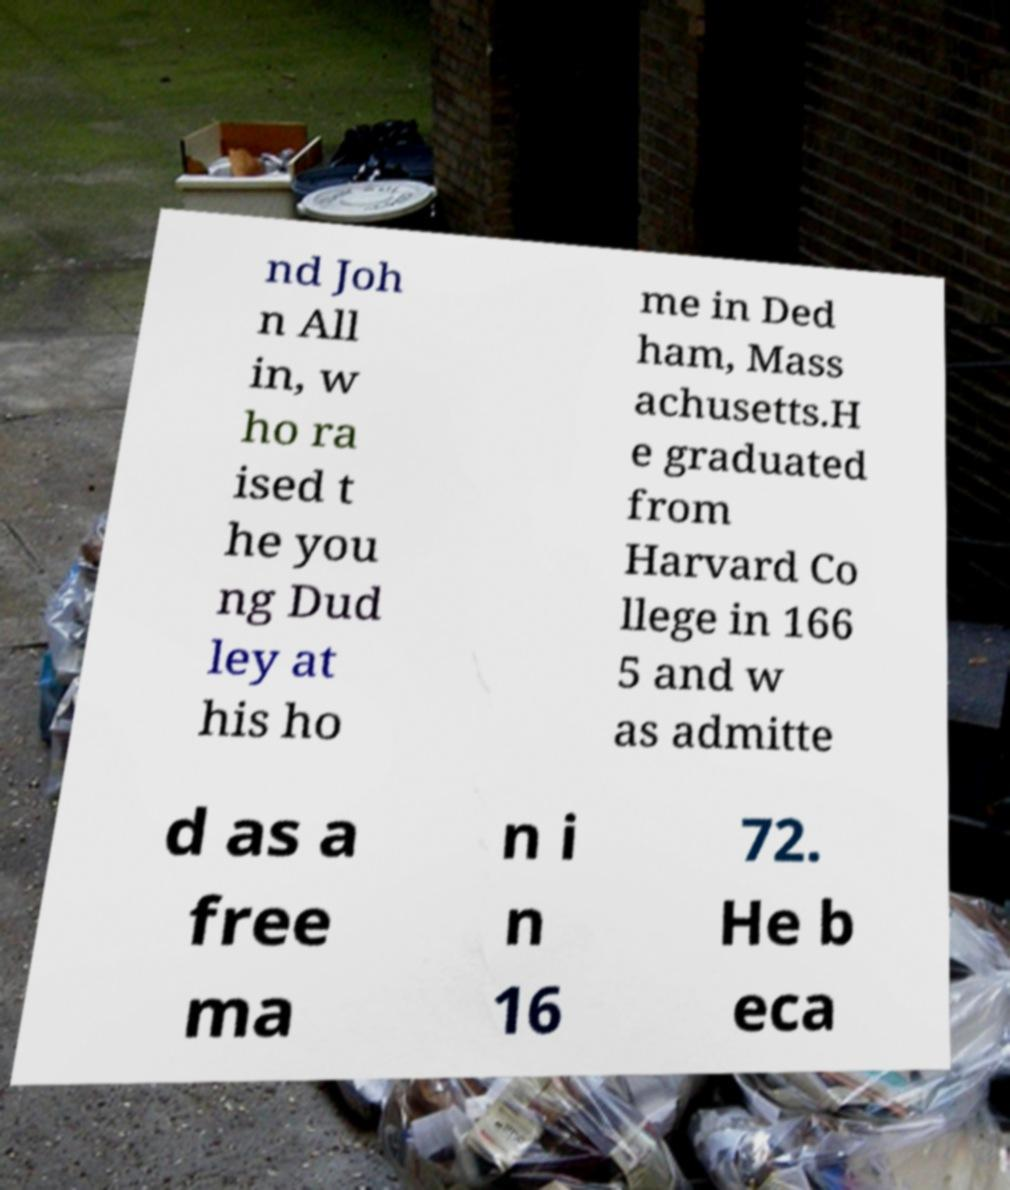Can you read and provide the text displayed in the image?This photo seems to have some interesting text. Can you extract and type it out for me? nd Joh n All in, w ho ra ised t he you ng Dud ley at his ho me in Ded ham, Mass achusetts.H e graduated from Harvard Co llege in 166 5 and w as admitte d as a free ma n i n 16 72. He b eca 